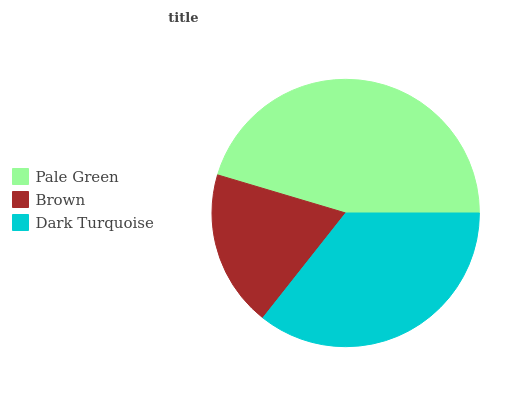Is Brown the minimum?
Answer yes or no. Yes. Is Pale Green the maximum?
Answer yes or no. Yes. Is Dark Turquoise the minimum?
Answer yes or no. No. Is Dark Turquoise the maximum?
Answer yes or no. No. Is Dark Turquoise greater than Brown?
Answer yes or no. Yes. Is Brown less than Dark Turquoise?
Answer yes or no. Yes. Is Brown greater than Dark Turquoise?
Answer yes or no. No. Is Dark Turquoise less than Brown?
Answer yes or no. No. Is Dark Turquoise the high median?
Answer yes or no. Yes. Is Dark Turquoise the low median?
Answer yes or no. Yes. Is Pale Green the high median?
Answer yes or no. No. Is Brown the low median?
Answer yes or no. No. 